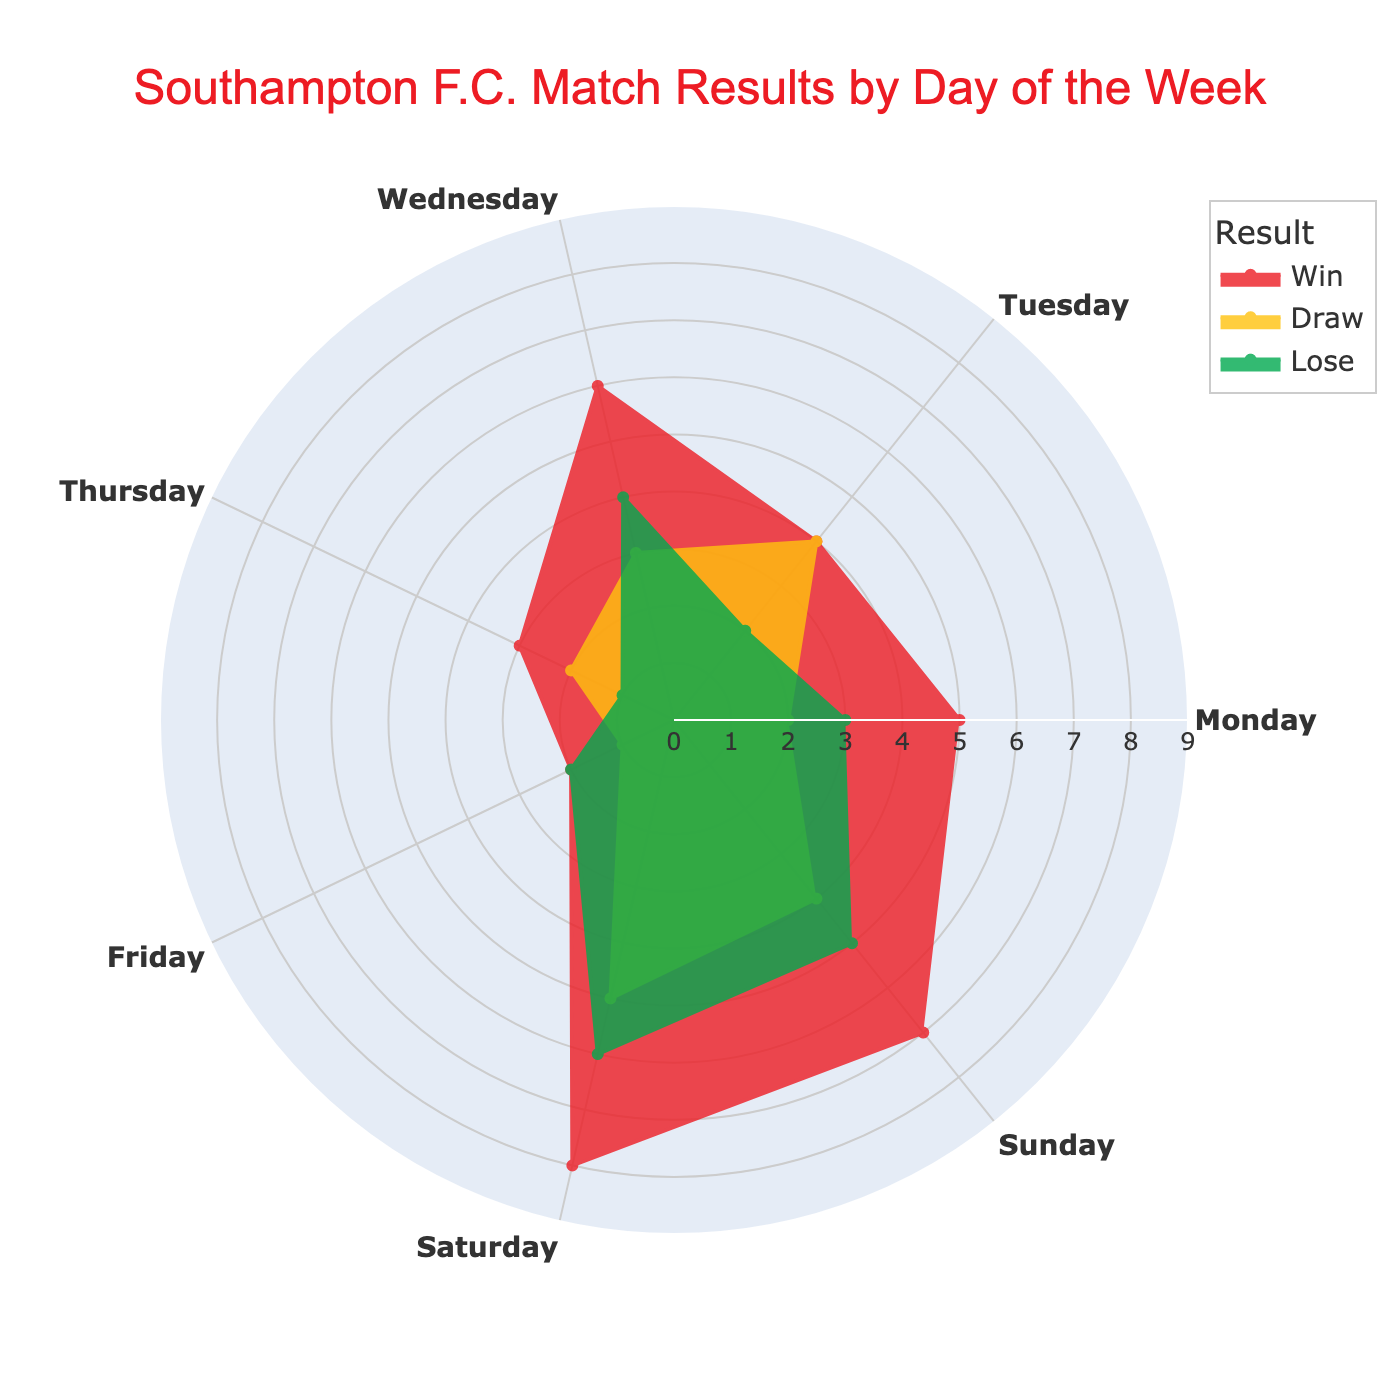What is the title of the figure? The title can be found at the top of the figure. It reads: "Southampton F.C. Match Results by Day of the Week"
Answer: Southampton F.C. Match Results by Day of the Week Which color represents Southampton F.C. wins in the rose chart? The color representing wins can be identified in the legend. It is a shade of red.
Answer: Red What day has the highest number of wins? To determine this, look at the red segments in the rose chart and identify which day has the furthest extent. Saturday has the longest red segment.
Answer: Saturday How many draws did Southampton F.C. have on Tuesdays? Locate the yellow segment (representing draws) for Tuesday on the chart and count the number of units. The yellow segment for Tuesday shows 4 draws.
Answer: 4 What is the total number of matches (win, draw, and lose) played on Sundays? To find the total, add the values of wins, draws, and losses for Sunday. 7 Wins + 4 Draws + 5 Losses = 16 matches.
Answer: 16 Which day has more losses, Saturday or Wednesday? Compare the length of the green segments for Saturday and Wednesday. Wednesday’s green segment is slightly longer, indicating there are more losses.
Answer: Wednesday On which day of the week did Southampton F.C. draw the least? The shortest yellow segment across the chart is observed on Friday and Thursday, both showing 1 draw.
Answer: Friday or Thursday How many more wins did Southampton F.C. have on Wednesdays compared to Thursdays? Subtract the number of wins on Thursday from the number on Wednesday. 6 Wins on Wednesday - 3 Wins on Thursday = 3 more wins.
Answer: 3 Summing up wins and draws, which day had the least successful matches? Calculate the total of wins and draws for each day and find the minimum. Friday has the least successful matches with 2 Wins + 1 Draw = 3.
Answer: Friday On which day did Southampton F.C. perform most consistently in terms of number of wins and losses being equal? Identify the day where the lengths of the red (wins) and green (losses) segments are roughly the same. Wednesday shows 6 Wins and 4 Losses, making it relatively close but not exactly equal; therefore, there isn’t a day with exact equality.
Answer: No exact match 